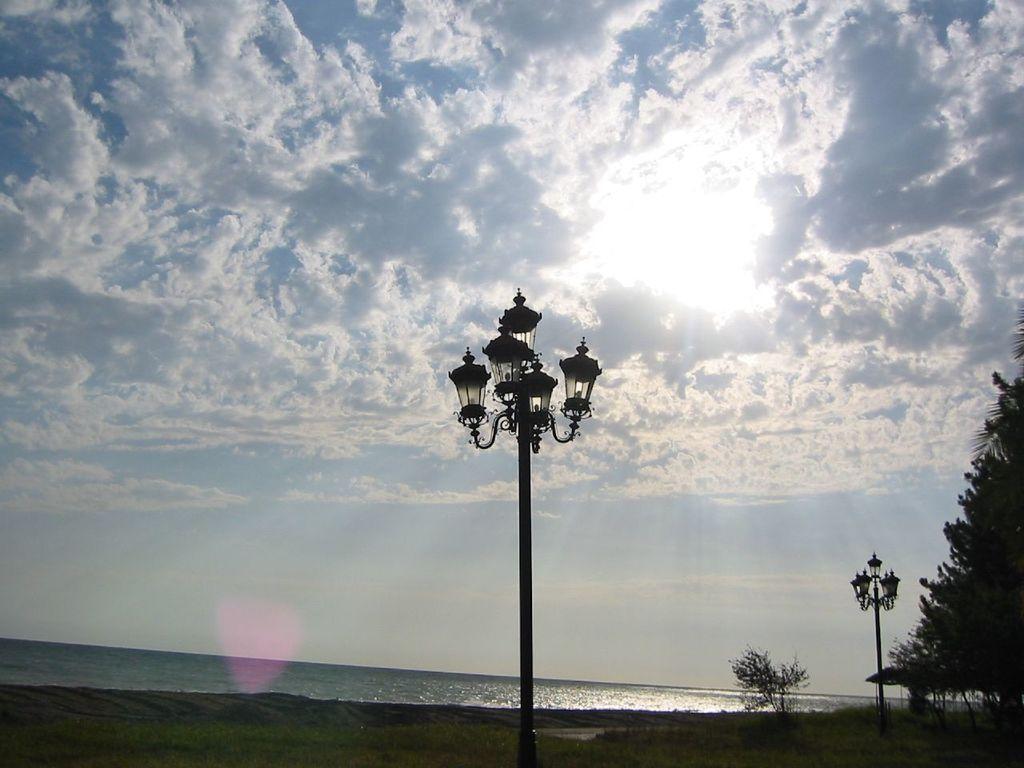Describe this image in one or two sentences. In this image, we can see lights, trees. At the top, there are clouds in the sky and at the bottom, there is water and ground. 